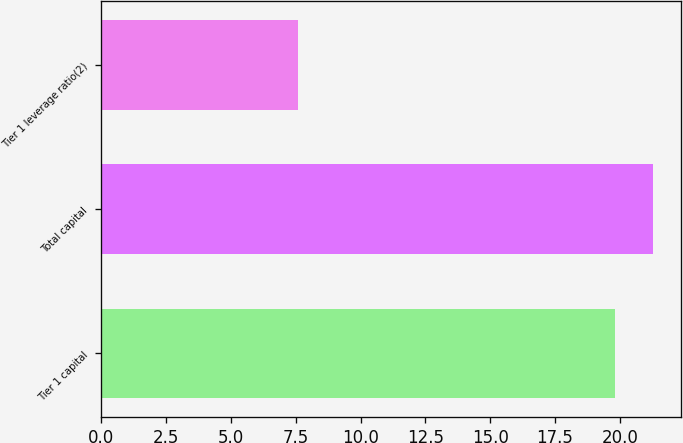Convert chart. <chart><loc_0><loc_0><loc_500><loc_500><bar_chart><fcel>Tier 1 capital<fcel>Total capital<fcel>Tier 1 leverage ratio(2)<nl><fcel>19.8<fcel>21.3<fcel>7.6<nl></chart> 